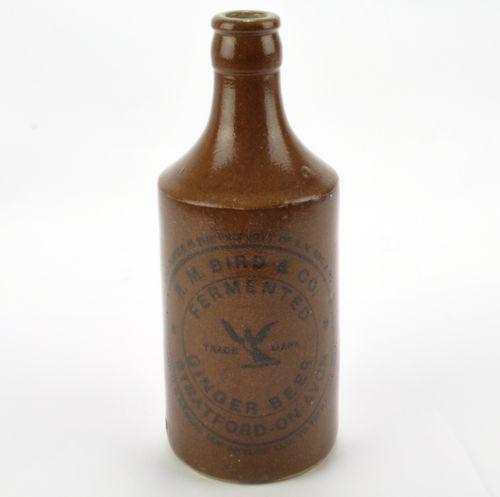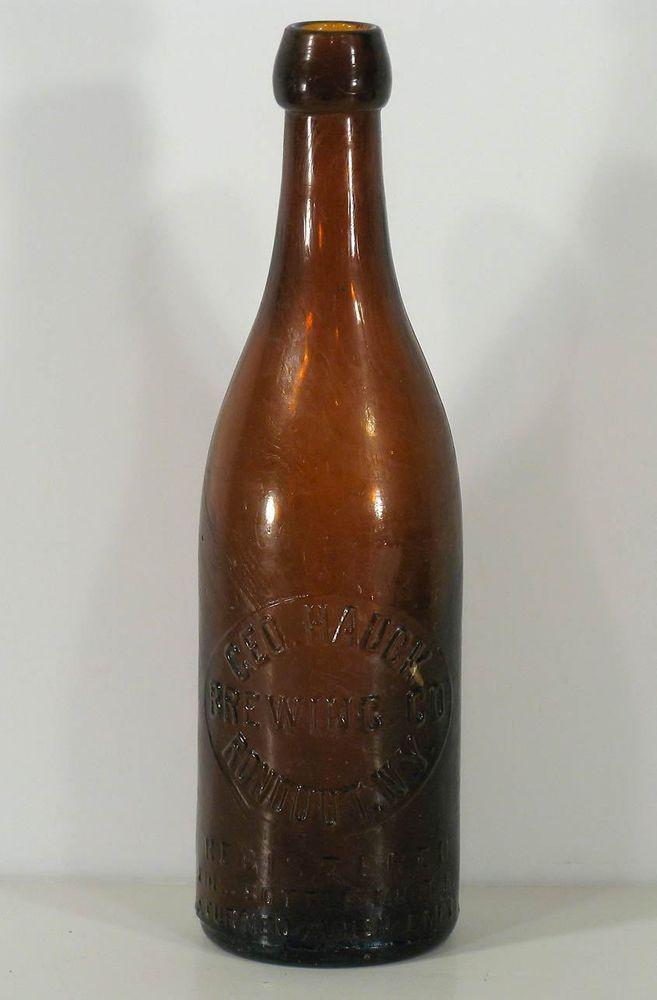The first image is the image on the left, the second image is the image on the right. Considering the images on both sides, is "There are a total of six bottles." valid? Answer yes or no. No. 